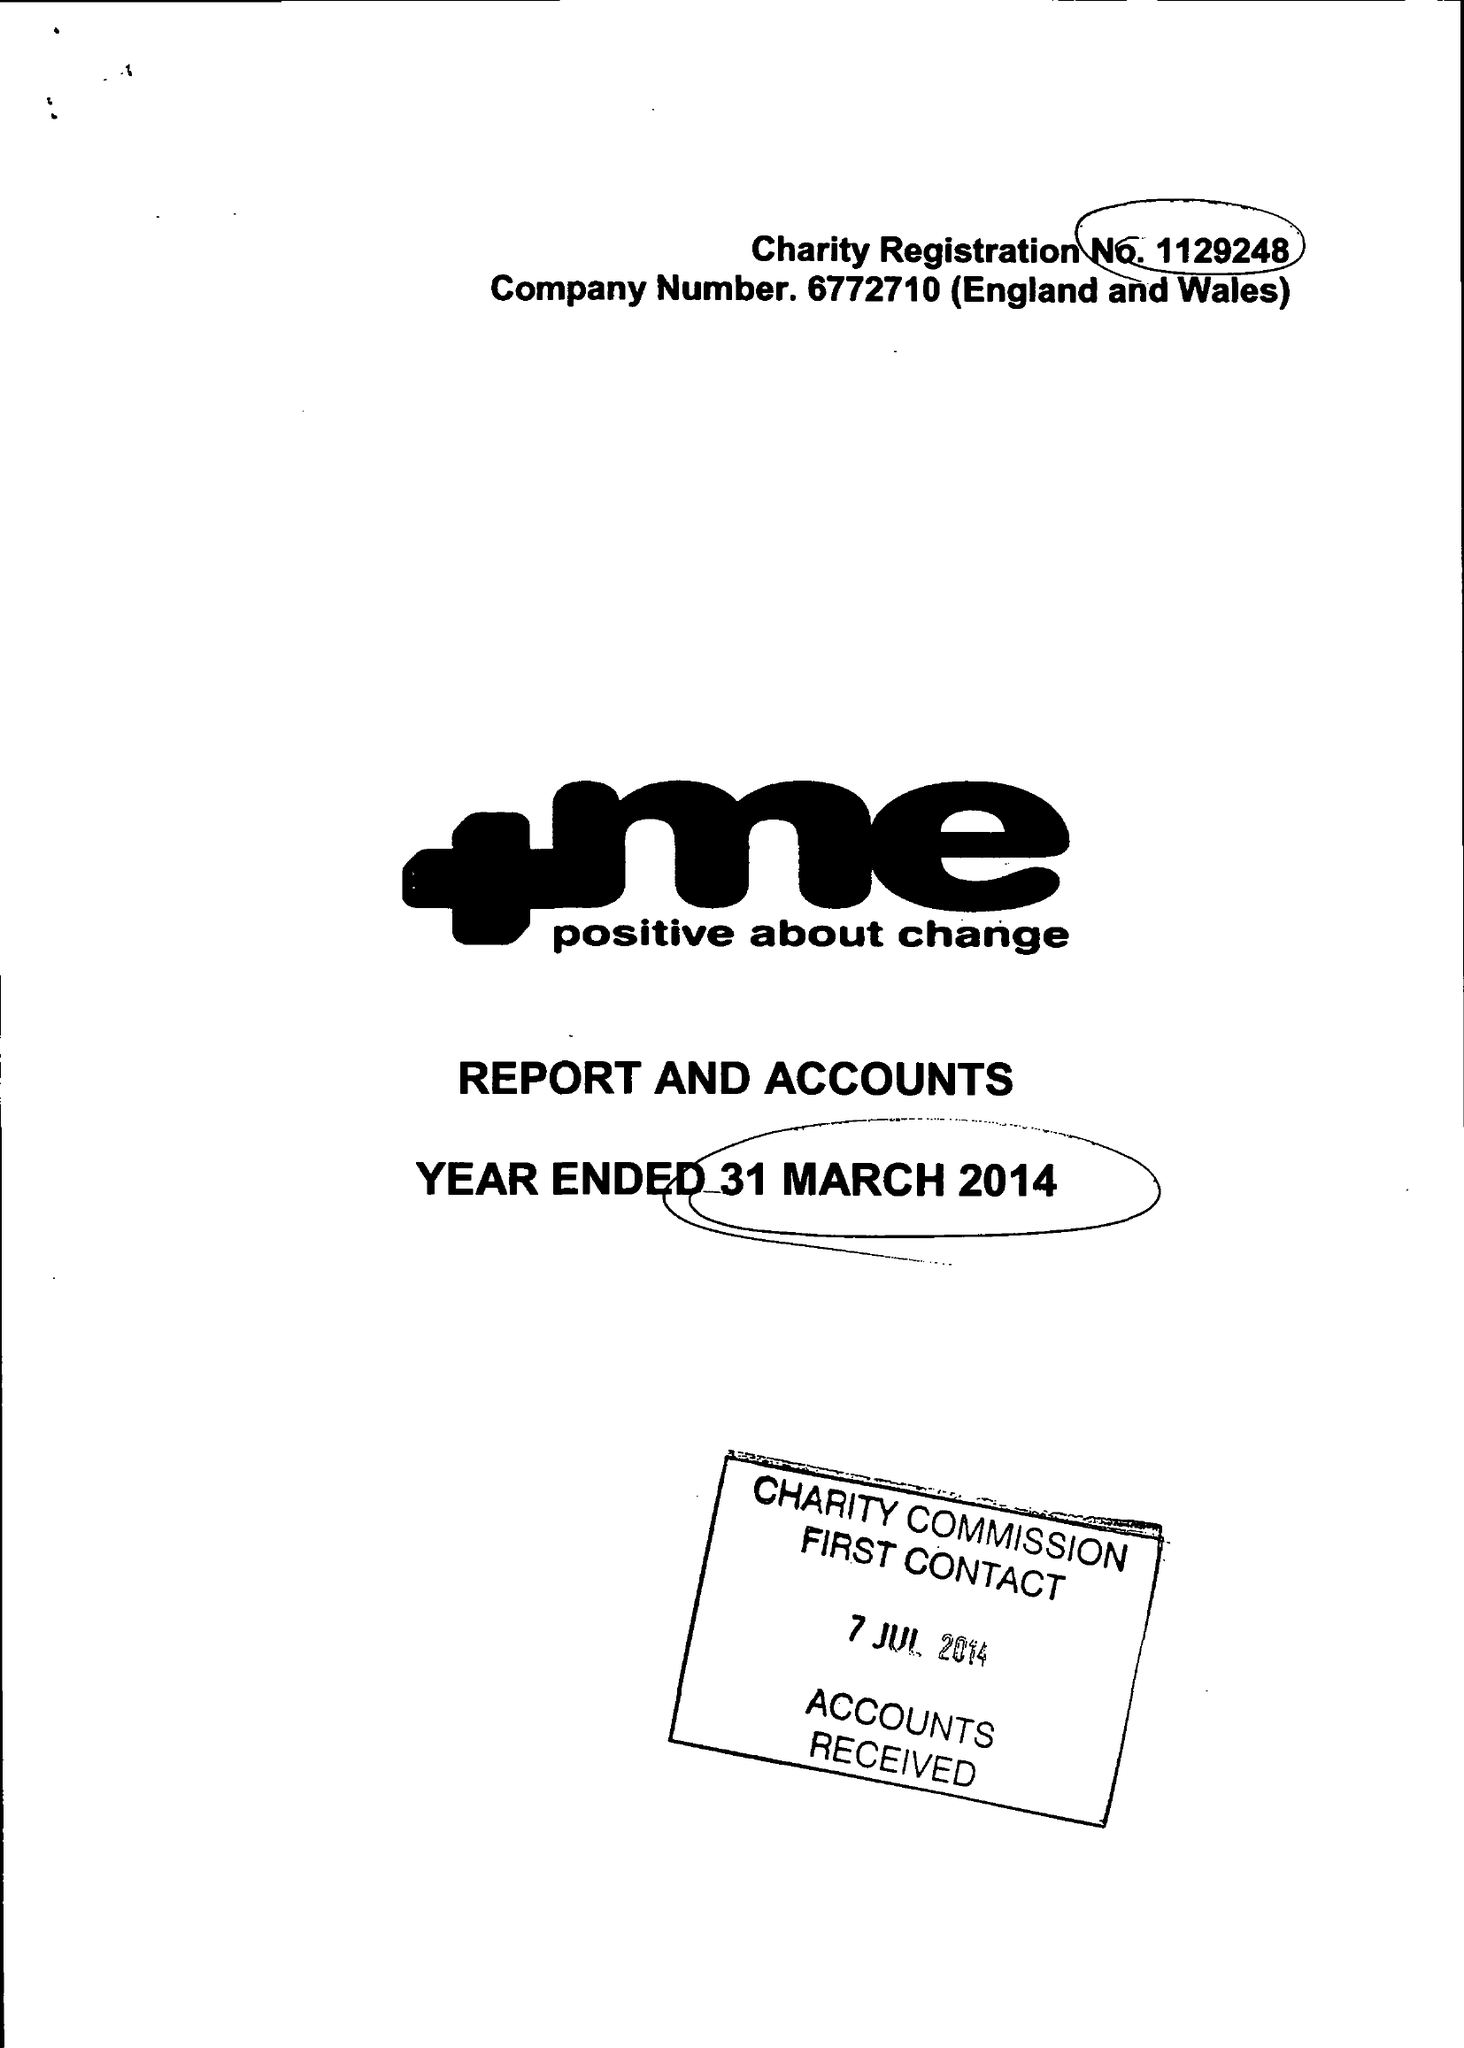What is the value for the address__street_line?
Answer the question using a single word or phrase. 23 QUEENS ROAD 